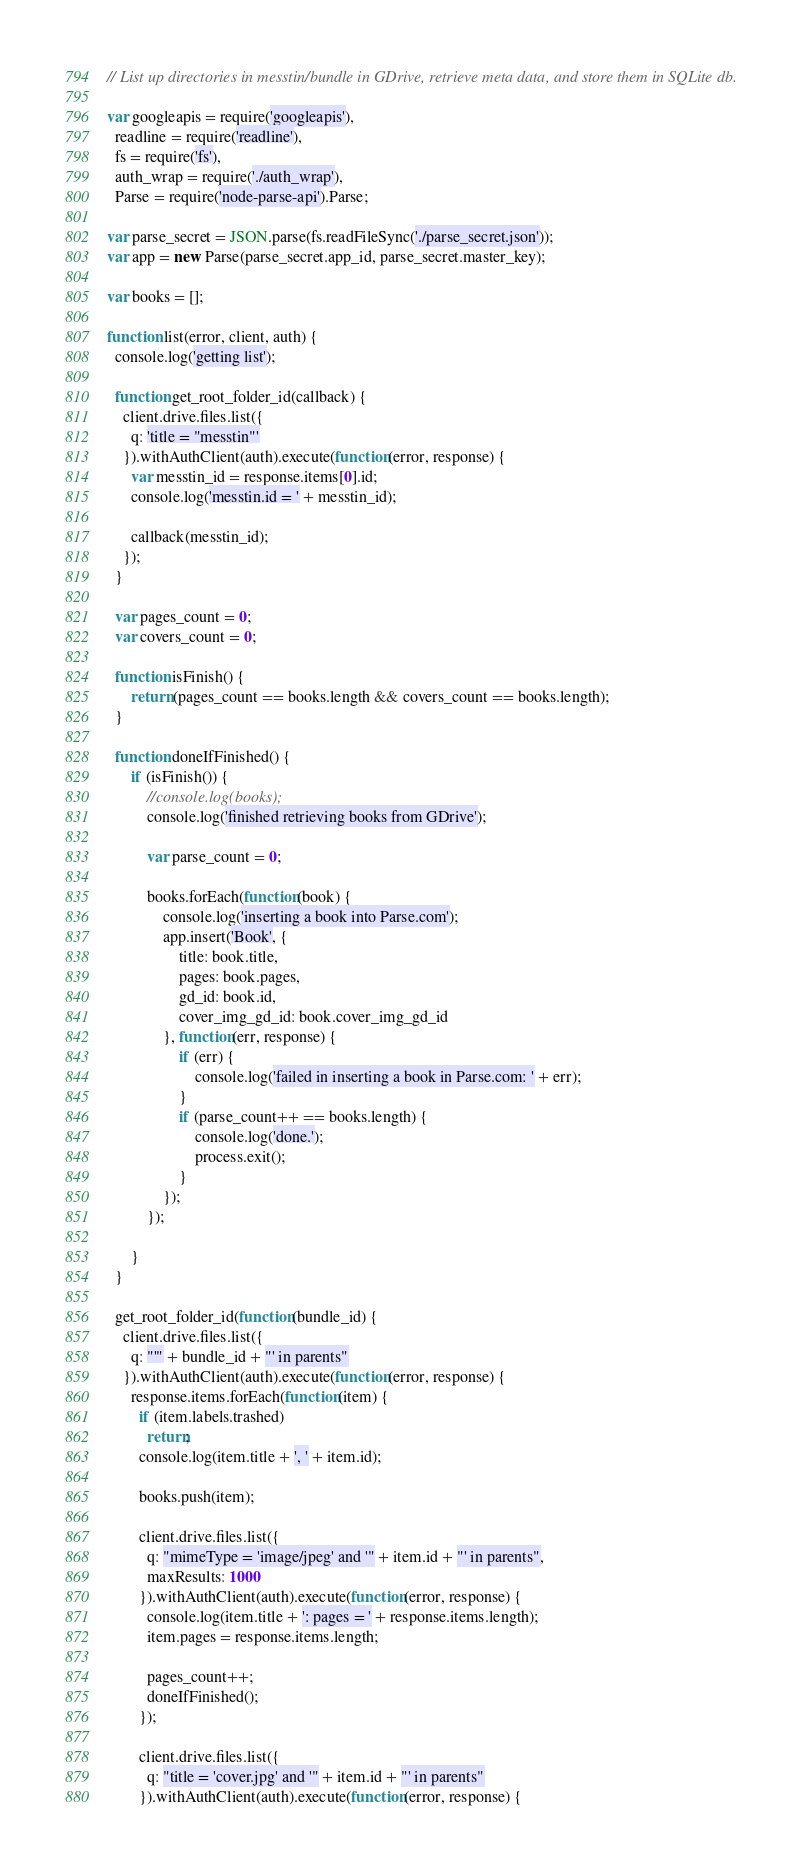Convert code to text. <code><loc_0><loc_0><loc_500><loc_500><_JavaScript_>// List up directories in messtin/bundle in GDrive, retrieve meta data, and store them in SQLite db.

var googleapis = require('googleapis'),
  readline = require('readline'),
  fs = require('fs'),
  auth_wrap = require('./auth_wrap'),
  Parse = require('node-parse-api').Parse;

var parse_secret = JSON.parse(fs.readFileSync('./parse_secret.json'));
var app = new Parse(parse_secret.app_id, parse_secret.master_key);

var books = [];

function list(error, client, auth) {
  console.log('getting list');

  function get_root_folder_id(callback) {
    client.drive.files.list({
      q: 'title = "messtin"'
    }).withAuthClient(auth).execute(function(error, response) {
      var messtin_id = response.items[0].id;
      console.log('messtin.id = ' + messtin_id);

      callback(messtin_id);
    });
  }

  var pages_count = 0;
  var covers_count = 0;

  function isFinish() {
      return (pages_count == books.length && covers_count == books.length);
  }

  function doneIfFinished() {
      if (isFinish()) {
          //console.log(books);
          console.log('finished retrieving books from GDrive');

          var parse_count = 0;

          books.forEach(function(book) {
              console.log('inserting a book into Parse.com');
              app.insert('Book', {
                  title: book.title,
                  pages: book.pages,
                  gd_id: book.id,
                  cover_img_gd_id: book.cover_img_gd_id
              }, function(err, response) {
                  if (err) {
                      console.log('failed in inserting a book in Parse.com: ' + err);
                  }
                  if (parse_count++ == books.length) {
                      console.log('done.');
                      process.exit();
                  }
              });
          });

      }
  }

  get_root_folder_id(function(bundle_id) {
    client.drive.files.list({
      q: "'" + bundle_id + "' in parents"
    }).withAuthClient(auth).execute(function(error, response) {
      response.items.forEach(function(item) {
        if (item.labels.trashed)
          return;
        console.log(item.title + ', ' + item.id);

        books.push(item);

        client.drive.files.list({
          q: "mimeType = 'image/jpeg' and '" + item.id + "' in parents",
          maxResults: 1000
        }).withAuthClient(auth).execute(function(error, response) {
          console.log(item.title + ': pages = ' + response.items.length);
          item.pages = response.items.length;

          pages_count++;
          doneIfFinished();
        });

        client.drive.files.list({
          q: "title = 'cover.jpg' and '" + item.id + "' in parents"
        }).withAuthClient(auth).execute(function(error, response) {</code> 